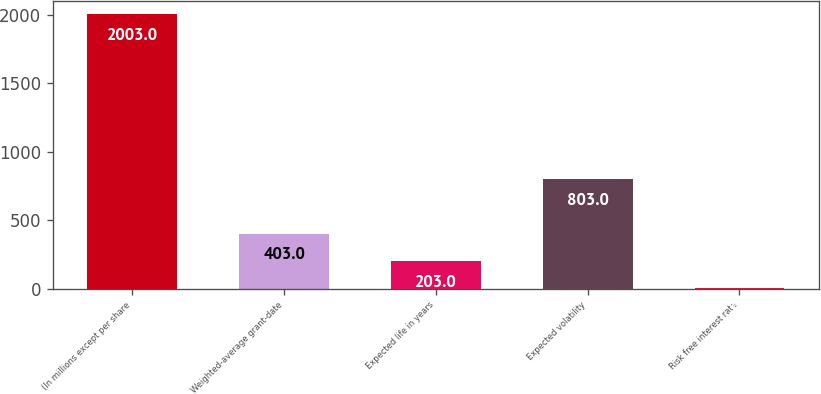Convert chart. <chart><loc_0><loc_0><loc_500><loc_500><bar_chart><fcel>(In millions except per share<fcel>Weighted-average grant-date<fcel>Expected life in years<fcel>Expected volatility<fcel>Risk free interest rate<nl><fcel>2003<fcel>403<fcel>203<fcel>803<fcel>3<nl></chart> 